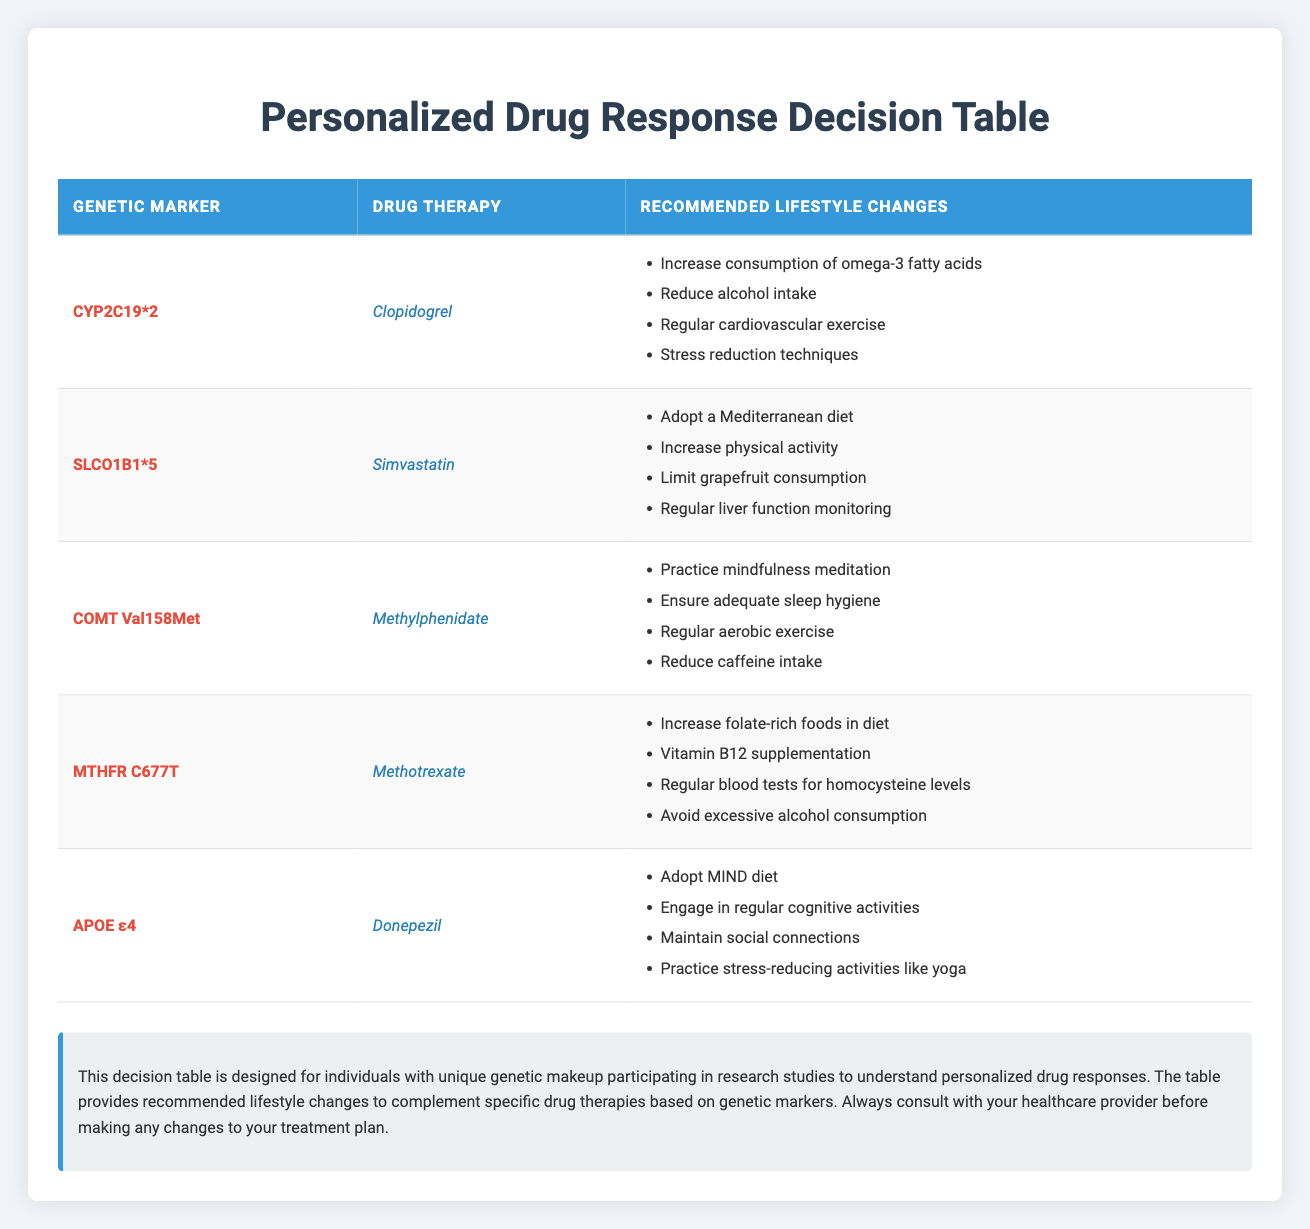What lifestyle change is recommended for those taking Clopidogrel with the CYP2C19*2 marker? According to the table, individuals taking Clopidogrel, particularly those with the CYP2C19*2 genetic marker, are advised to increase consumption of omega-3 fatty acids, reduce alcohol intake, engage in regular cardiovascular exercise, and implement stress reduction techniques.
Answer: Increase consumption of omega-3 fatty acids Is it true that Simvastatin is recommended alongside regular liver function monitoring for those with the SLCO1B1*5 marker? Yes, the table clearly lists regular liver function monitoring as one of the lifestyle recommendations for individuals taking Simvastatin and having the SLCO1B1*5 genetic marker.
Answer: Yes How many lifestyle changes are suggested for those with the MTHFR C677T genetic marker? The table outlines four specific lifestyle changes for individuals with the MTHFR C677T marker taking Methotrexate: increase folate-rich foods in diet, vitamin B12 supplementation, regular blood tests for homocysteine levels, and avoid excessive alcohol consumption. Therefore, the total is four lifestyle changes.
Answer: Four What are the recommendations for individuals with the APOE ε4 marker taking Donepezil? Individuals with the APOE ε4 marker taking Donepezil are recommended to adopt the MIND diet, engage in regular cognitive activities, maintain social connections, and practice stress-reducing activities like yoga. These recommendations encompass looking after mental and social well-being.
Answer: Adopt MIND diet, engage in cognitive activities, maintain social connections, practice stress-reducing activities Which drug therapy has recommendations to limit grapefruit consumption? The drug therapy associated with recommendations to limit grapefruit consumption is Simvastatin, specifically for those with the SLCO1B1*5 genetic marker. The table directly mentions this as one of the lifestyle changes.
Answer: Simvastatin 